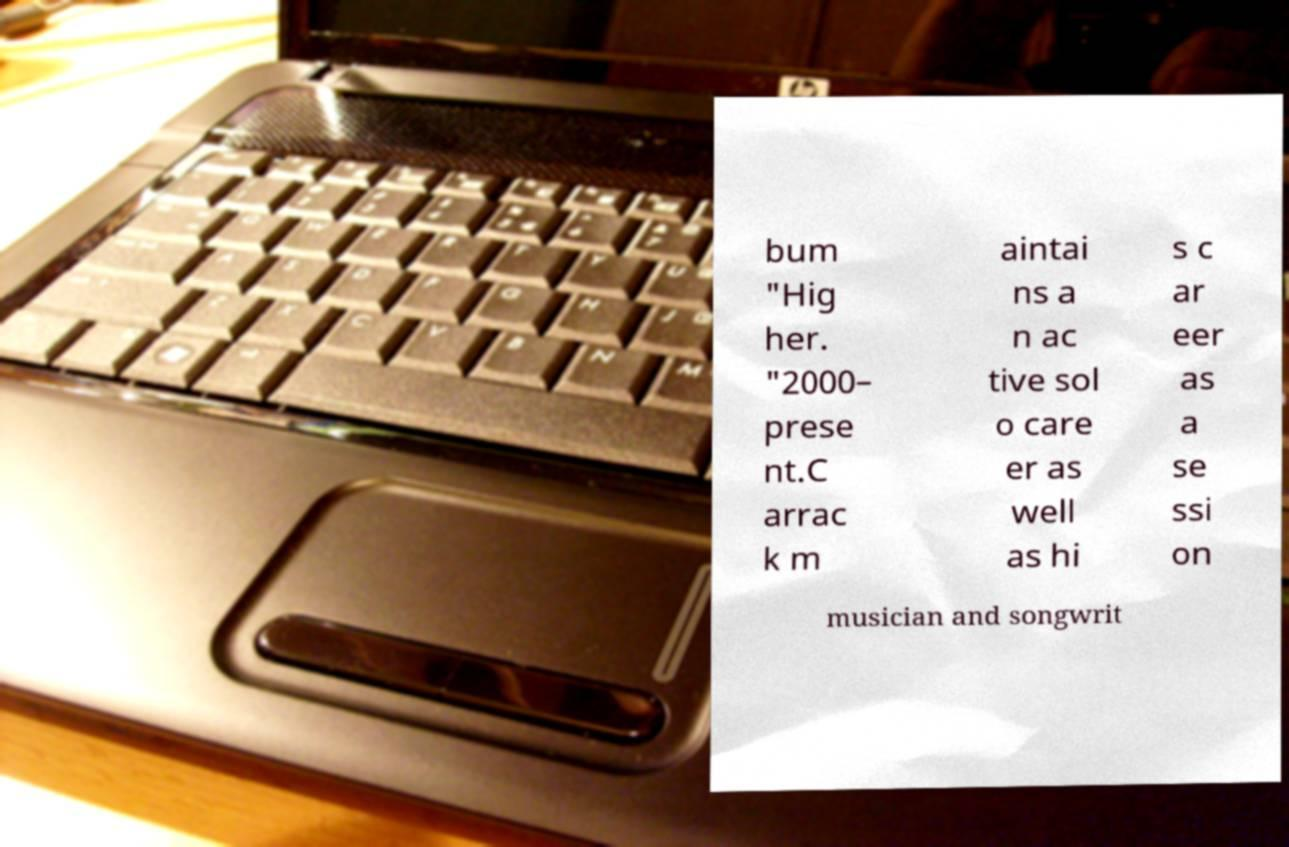Could you assist in decoding the text presented in this image and type it out clearly? bum "Hig her. "2000– prese nt.C arrac k m aintai ns a n ac tive sol o care er as well as hi s c ar eer as a se ssi on musician and songwrit 